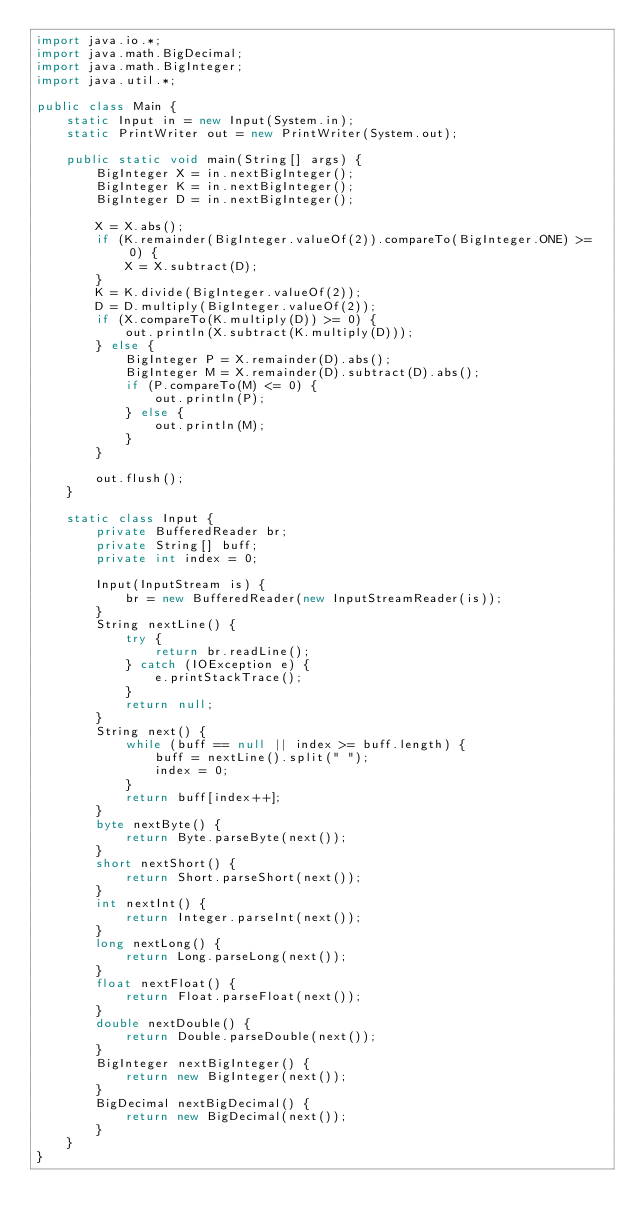Convert code to text. <code><loc_0><loc_0><loc_500><loc_500><_Java_>import java.io.*;
import java.math.BigDecimal;
import java.math.BigInteger;
import java.util.*;

public class Main {
    static Input in = new Input(System.in);
    static PrintWriter out = new PrintWriter(System.out);

    public static void main(String[] args) {
        BigInteger X = in.nextBigInteger();
        BigInteger K = in.nextBigInteger();
        BigInteger D = in.nextBigInteger();

        X = X.abs();
        if (K.remainder(BigInteger.valueOf(2)).compareTo(BigInteger.ONE) >= 0) {
            X = X.subtract(D);
        }
        K = K.divide(BigInteger.valueOf(2));
        D = D.multiply(BigInteger.valueOf(2));
        if (X.compareTo(K.multiply(D)) >= 0) {
            out.println(X.subtract(K.multiply(D)));
        } else {
            BigInteger P = X.remainder(D).abs();
            BigInteger M = X.remainder(D).subtract(D).abs();
            if (P.compareTo(M) <= 0) {
                out.println(P);
            } else {
                out.println(M);
            }
        }

        out.flush();
    }

    static class Input {
        private BufferedReader br;
        private String[] buff;
        private int index = 0;

        Input(InputStream is) {
            br = new BufferedReader(new InputStreamReader(is));
        }
        String nextLine() {
            try {
                return br.readLine();
            } catch (IOException e) {
                e.printStackTrace();
            }
            return null;
        }
        String next() {
            while (buff == null || index >= buff.length) {
                buff = nextLine().split(" ");
                index = 0;
            }
            return buff[index++];
        }
        byte nextByte() {
            return Byte.parseByte(next());
        }
        short nextShort() {
            return Short.parseShort(next());
        }
        int nextInt() {
            return Integer.parseInt(next());
        }
        long nextLong() {
            return Long.parseLong(next());
        }
        float nextFloat() {
            return Float.parseFloat(next());
        }
        double nextDouble() {
            return Double.parseDouble(next());
        }
        BigInteger nextBigInteger() {
            return new BigInteger(next());
        }
        BigDecimal nextBigDecimal() {
            return new BigDecimal(next());
        }
    }
}
</code> 